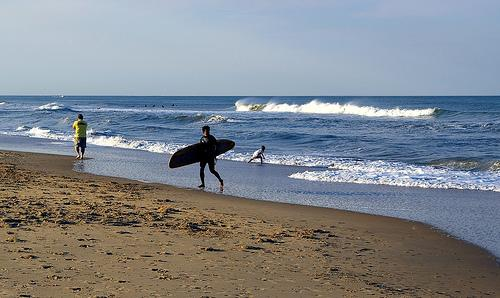Why is the small child in the water? playing 